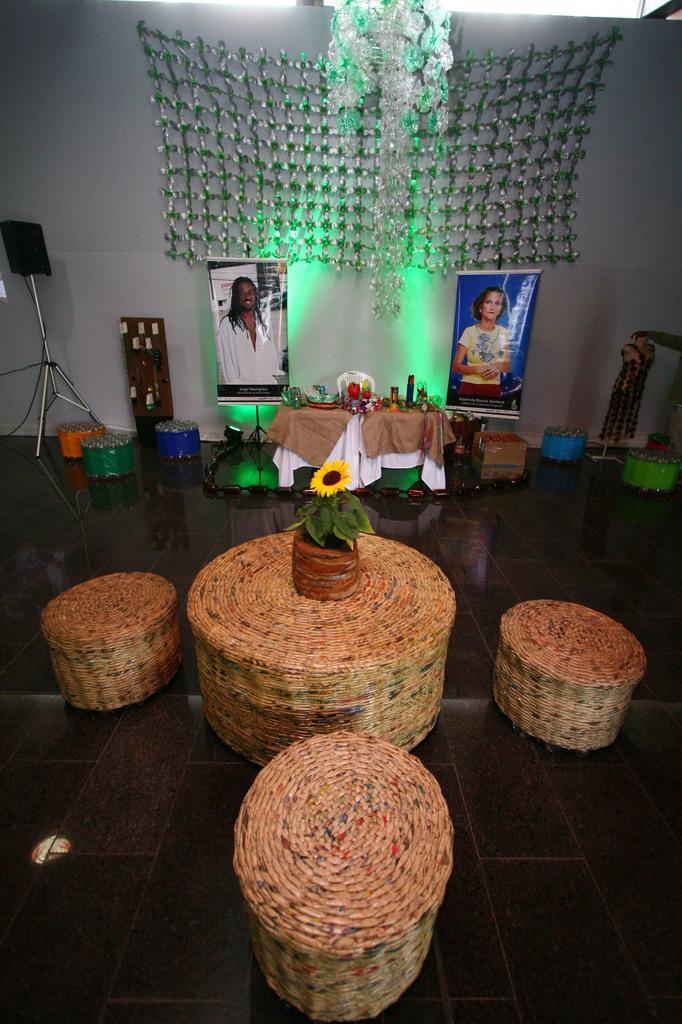Can you describe this image briefly? In this image I can see few cane chairs, in front I can see a flower in the basket which is in yellow color, background I can see two banners. I can also see few bottles on the table and the wall is in white color. 